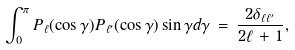<formula> <loc_0><loc_0><loc_500><loc_500>\int _ { 0 } ^ { \pi } P _ { \ell } ( \cos \gamma ) P _ { \ell ^ { \prime } } ( \cos \gamma ) \sin \gamma d \gamma \, = \, \frac { 2 \delta _ { \ell \ell ^ { \prime } } } { 2 \ell \, + \, 1 } ,</formula> 